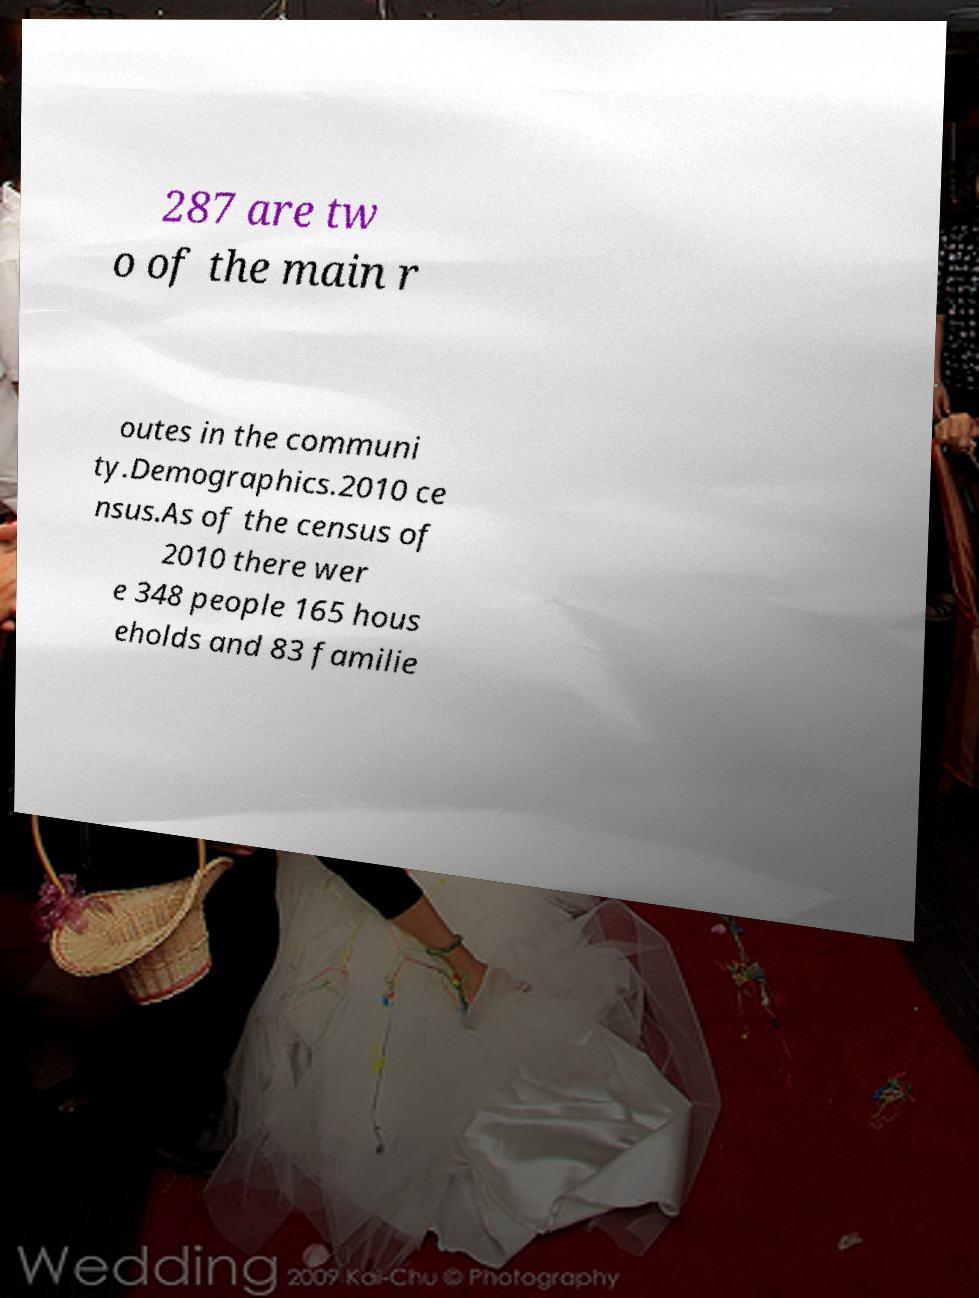For documentation purposes, I need the text within this image transcribed. Could you provide that? 287 are tw o of the main r outes in the communi ty.Demographics.2010 ce nsus.As of the census of 2010 there wer e 348 people 165 hous eholds and 83 familie 